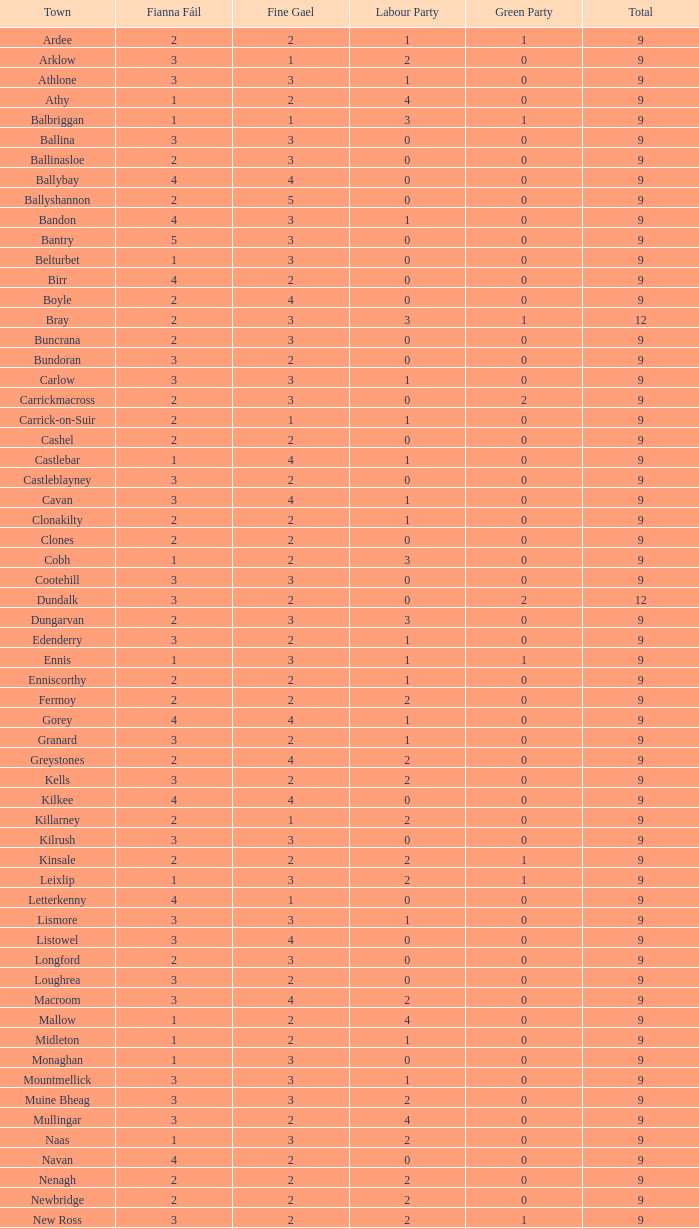What is the lowest number in the Labour Party for the Fianna Fail higher than 5? None. 